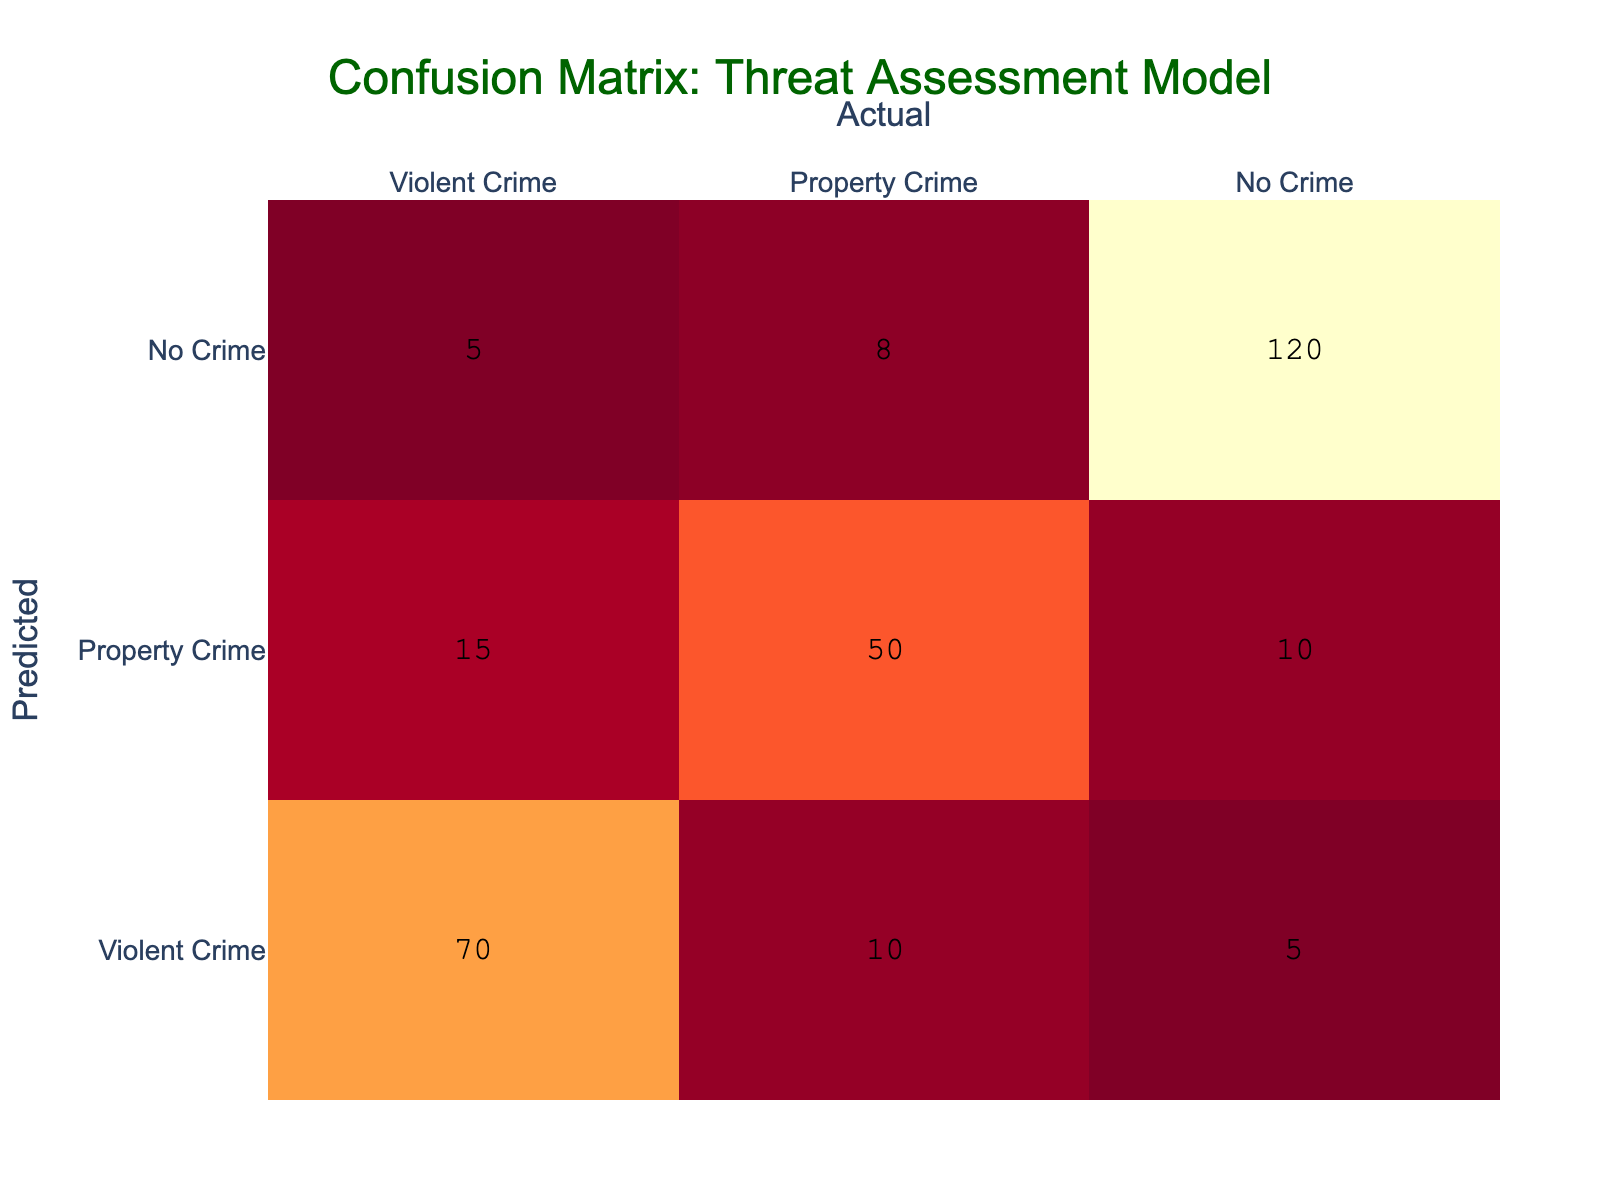What is the number of true positive predictions for violent crime? A true positive occurs when the model correctly predicts an event that actually happened. In this case, the true positive for violent crime is found in the cell that corresponds to the predicted "Violent Crime" and the actual "Violent Crime." The value in this cell is 70.
Answer: 70 What is the total number of predictions made for property crime? To find the total predictions for property crime, sum up all the values in the "Property Crime" row. The values are 15 (for violent crime), 50 (for property crime), and 10 (for no crime). Summing these gives 15 + 50 + 10 = 75.
Answer: 75 Is the model better at predicting violent crimes compared to property crimes? To determine this, we compare the true positives for each type. For violent crime, the true positive is 70, and for property crime, it is 50. Since 70 is greater than 50, the model is better at predicting violent crimes.
Answer: Yes What is the total number of actual no crime instances predicted as a crime? We need to calculate the number of false positives for the "No Crime" category. This includes both violent crime and property crime predictions that were incorrectly classified as a crime. From the table, there are 5 (predicted violent) + 8 (predicted property) = 13 instances that were predicted as a crime while the actual situation was "No Crime."
Answer: 13 What percentage of actual violent crimes were predicted correctly by the model? To determine this percentage, divide the true positive predictions of violent crime (70) by the total actual violent crimes, which is the sum of the corresponding row (70 + 10 + 5 = 85). The calculation is (70 / 85) * 100 = 82.35%.
Answer: 82.35% How many total instances were there of no crime predicted as property crime? Here, we look for false negatives in the "No Crime" category that were wrongly predicted as property crime. There are 10 instances in the "No Crime" row column that were predicted as property crime. This value is directly taken from the confusion matrix.
Answer: 10 What is the difference between the number of predictions for violent crime and no crime? To find this difference, we first calculate the total predictions for violent crime (sum of Violent Crime row) as 70 + 10 + 5 = 85. For no crime, the total (sum of No Crime row) is 5 + 8 + 120 = 133. Then, taking the difference gives us 85 - 133 = -48.
Answer: -48 What is the accuracy of the model in predicting no crimes? The accuracy for no crimes is calculated using the proportion of true negatives to the total predictions for all categories. True negatives for no crimes are 120, the actual total is 120 + 5 + 8 = 133. Hence, the accuracy is 120/133 = 0.9015, or approximately 90.15%.
Answer: 90.15% 